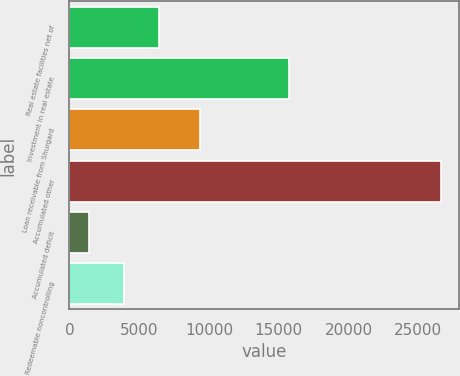<chart> <loc_0><loc_0><loc_500><loc_500><bar_chart><fcel>Real estate facilities net of<fcel>Investment in real estate<fcel>Loan receivable from Shurgard<fcel>Accumulated other<fcel>Accumulated deficit<fcel>Redeemable noncontrolling<nl><fcel>6431.8<fcel>15764<fcel>9342<fcel>26591<fcel>1392<fcel>3911.9<nl></chart> 